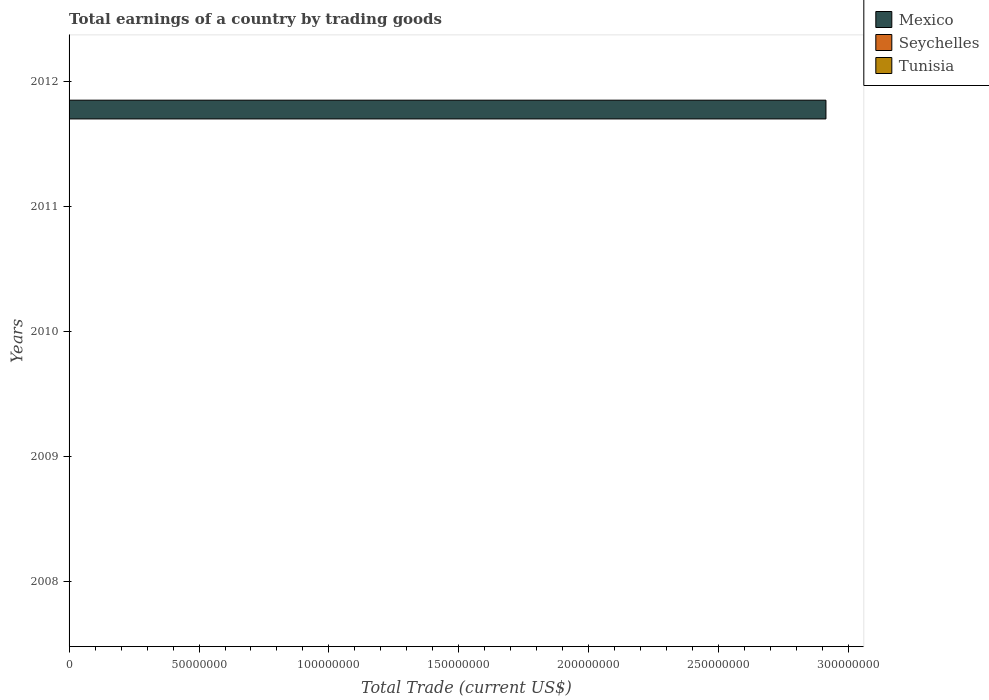How many different coloured bars are there?
Keep it short and to the point. 1. Are the number of bars per tick equal to the number of legend labels?
Keep it short and to the point. No. Are the number of bars on each tick of the Y-axis equal?
Ensure brevity in your answer.  No. How many bars are there on the 5th tick from the top?
Your answer should be compact. 0. How many bars are there on the 4th tick from the bottom?
Provide a short and direct response. 0. In how many cases, is the number of bars for a given year not equal to the number of legend labels?
Offer a very short reply. 5. Across all years, what is the maximum total earnings in Mexico?
Make the answer very short. 2.91e+08. Across all years, what is the minimum total earnings in Seychelles?
Provide a succinct answer. 0. What is the total total earnings in Mexico in the graph?
Your answer should be compact. 2.91e+08. What is the difference between the total earnings in Tunisia in 2008 and the total earnings in Seychelles in 2012?
Keep it short and to the point. 0. In how many years, is the total earnings in Mexico greater than 240000000 US$?
Your response must be concise. 1. What is the difference between the highest and the lowest total earnings in Mexico?
Provide a succinct answer. 2.91e+08. How many bars are there?
Ensure brevity in your answer.  1. What is the difference between two consecutive major ticks on the X-axis?
Ensure brevity in your answer.  5.00e+07. Are the values on the major ticks of X-axis written in scientific E-notation?
Give a very brief answer. No. Does the graph contain any zero values?
Give a very brief answer. Yes. Does the graph contain grids?
Your answer should be very brief. No. Where does the legend appear in the graph?
Provide a short and direct response. Top right. What is the title of the graph?
Offer a terse response. Total earnings of a country by trading goods. Does "Mauritania" appear as one of the legend labels in the graph?
Offer a very short reply. No. What is the label or title of the X-axis?
Ensure brevity in your answer.  Total Trade (current US$). What is the label or title of the Y-axis?
Offer a terse response. Years. What is the Total Trade (current US$) in Tunisia in 2008?
Your response must be concise. 0. What is the Total Trade (current US$) of Mexico in 2009?
Give a very brief answer. 0. What is the Total Trade (current US$) of Seychelles in 2009?
Offer a terse response. 0. What is the Total Trade (current US$) of Tunisia in 2009?
Give a very brief answer. 0. What is the Total Trade (current US$) of Mexico in 2010?
Your answer should be very brief. 0. What is the Total Trade (current US$) of Seychelles in 2010?
Your answer should be compact. 0. What is the Total Trade (current US$) in Tunisia in 2010?
Ensure brevity in your answer.  0. What is the Total Trade (current US$) in Tunisia in 2011?
Your answer should be compact. 0. What is the Total Trade (current US$) in Mexico in 2012?
Offer a terse response. 2.91e+08. What is the Total Trade (current US$) in Tunisia in 2012?
Offer a very short reply. 0. Across all years, what is the maximum Total Trade (current US$) in Mexico?
Your answer should be very brief. 2.91e+08. Across all years, what is the minimum Total Trade (current US$) of Mexico?
Make the answer very short. 0. What is the total Total Trade (current US$) of Mexico in the graph?
Ensure brevity in your answer.  2.91e+08. What is the average Total Trade (current US$) in Mexico per year?
Give a very brief answer. 5.82e+07. What is the difference between the highest and the lowest Total Trade (current US$) of Mexico?
Give a very brief answer. 2.91e+08. 